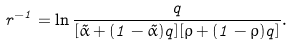<formula> <loc_0><loc_0><loc_500><loc_500>r ^ { - 1 } = \ln \frac { q } { [ \tilde { \alpha } + ( 1 - \tilde { \alpha } ) q ] [ \rho + ( 1 - \rho ) q ] } .</formula> 